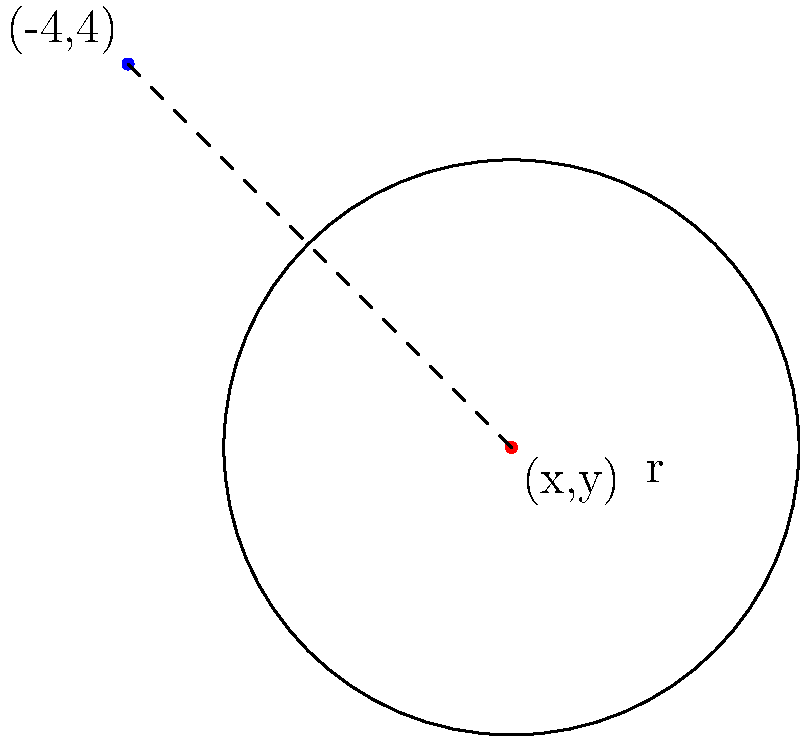In an Android XML layout, a circular progress bar is defined with a radius of 3dp and its top-left corner positioned at (-4,4). What are the coordinates (x,y) of the progress bar's center point? To find the center point of the circular progress bar, we need to follow these steps:

1. Understand the given information:
   - The top-left corner of the progress bar is at (-4,4)
   - The radius of the progress bar is 3dp

2. Realize that the center point is offset from the top-left corner by the radius in both x and y directions:
   - x-offset = radius = 3
   - y-offset = -radius = -3 (negative because we're moving down)

3. Calculate the x-coordinate of the center:
   $x = -4 + 3 = -1$

4. Calculate the y-coordinate of the center:
   $y = 4 - 3 = 1$

5. Combine the coordinates:
   The center point is at (-1,1)

This approach is useful when working with legacy XML layouts in Android development, as it allows you to determine the actual position of UI elements based on their defined attributes.
Answer: (-1,1) 